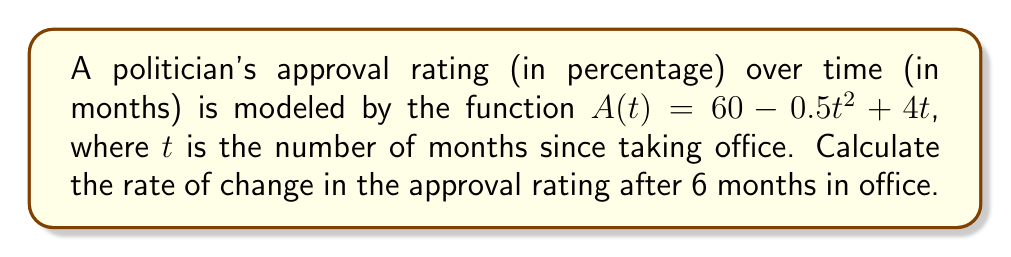Can you solve this math problem? To find the rate of change in the approval rating after 6 months, we need to calculate the derivative of the function $A(t)$ and evaluate it at $t=6$. 

Step 1: Find the derivative of $A(t)$
$$A(t) = 60 - 0.5t^2 + 4t$$
$$A'(t) = -t + 4$$

Step 2: Evaluate $A'(t)$ at $t=6$
$$A'(6) = -6 + 4 = -2$$

The negative value indicates that the approval rating is decreasing at this point in time.
Answer: $-2\%$ per month 